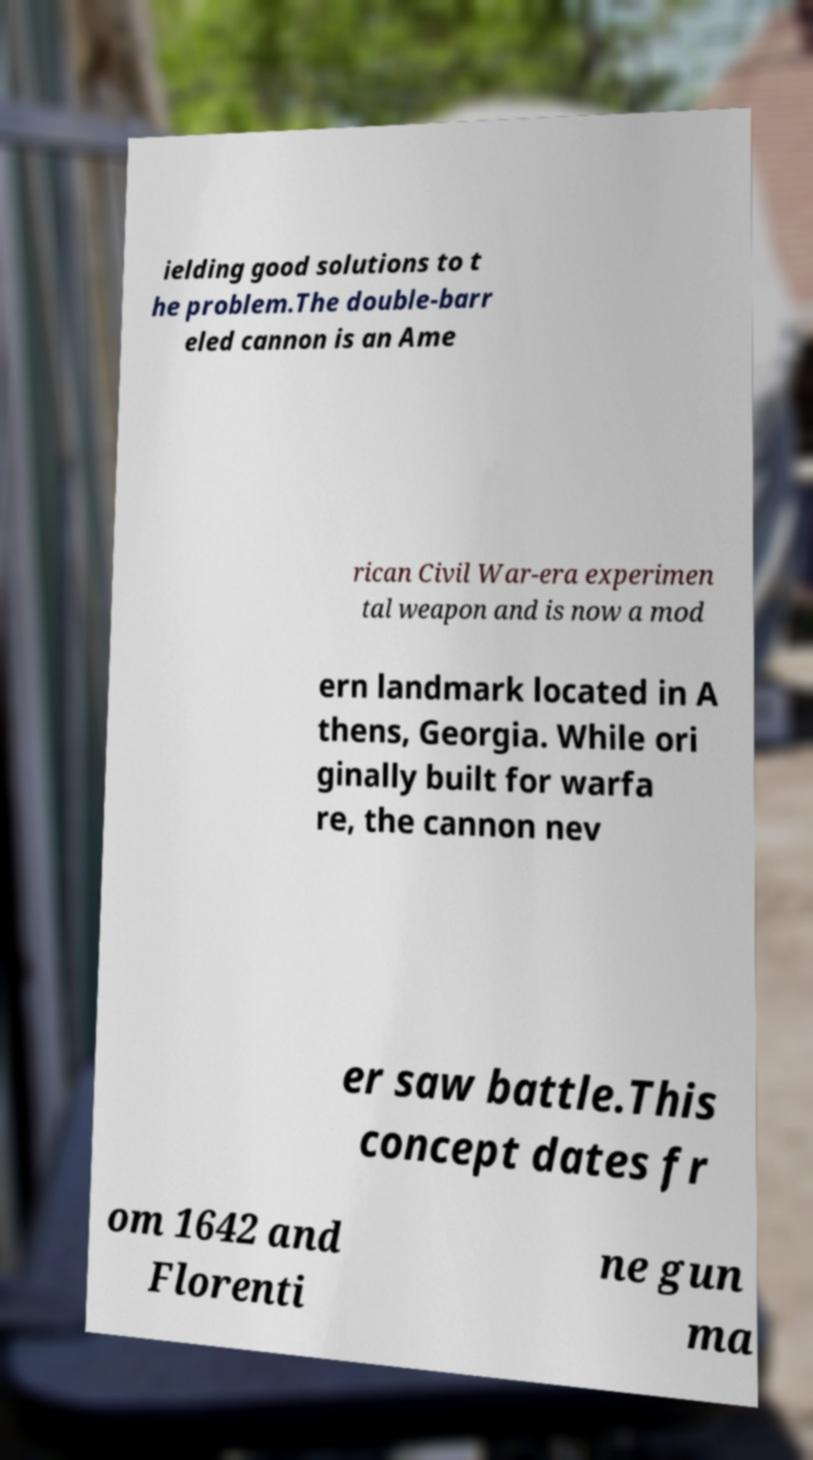Could you assist in decoding the text presented in this image and type it out clearly? ielding good solutions to t he problem.The double-barr eled cannon is an Ame rican Civil War-era experimen tal weapon and is now a mod ern landmark located in A thens, Georgia. While ori ginally built for warfa re, the cannon nev er saw battle.This concept dates fr om 1642 and Florenti ne gun ma 